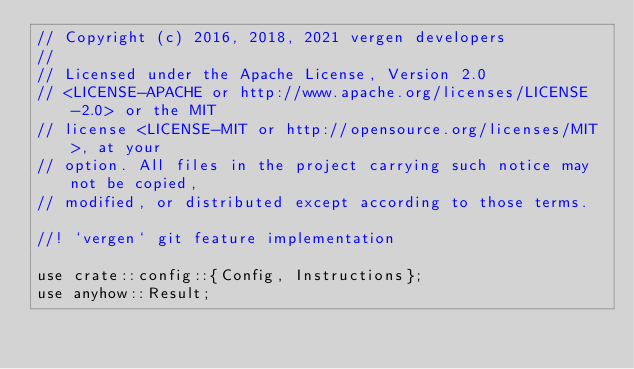<code> <loc_0><loc_0><loc_500><loc_500><_Rust_>// Copyright (c) 2016, 2018, 2021 vergen developers
//
// Licensed under the Apache License, Version 2.0
// <LICENSE-APACHE or http://www.apache.org/licenses/LICENSE-2.0> or the MIT
// license <LICENSE-MIT or http://opensource.org/licenses/MIT>, at your
// option. All files in the project carrying such notice may not be copied,
// modified, or distributed except according to those terms.

//! `vergen` git feature implementation

use crate::config::{Config, Instructions};
use anyhow::Result;</code> 